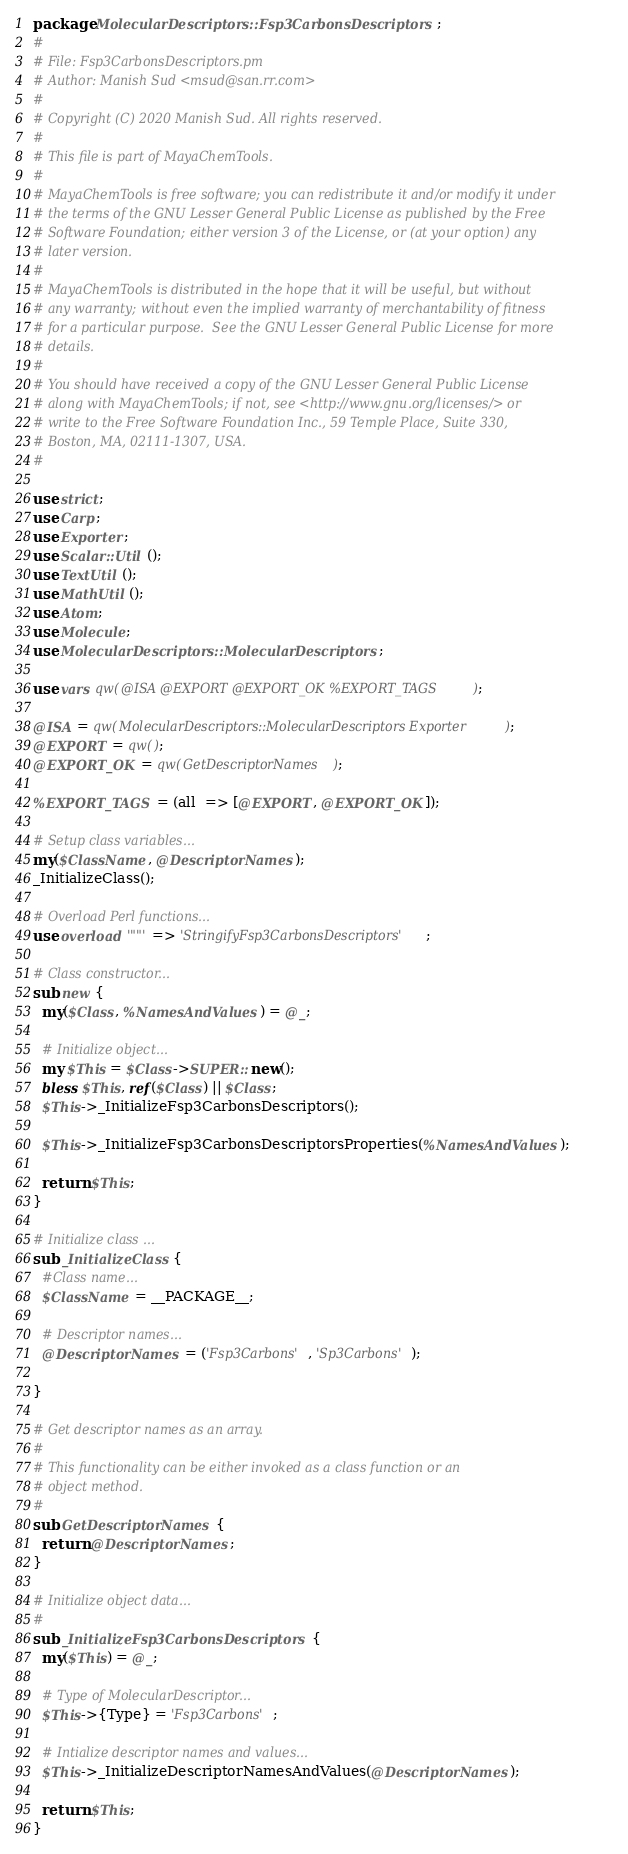Convert code to text. <code><loc_0><loc_0><loc_500><loc_500><_Perl_>package MolecularDescriptors::Fsp3CarbonsDescriptors;
#
# File: Fsp3CarbonsDescriptors.pm
# Author: Manish Sud <msud@san.rr.com>
#
# Copyright (C) 2020 Manish Sud. All rights reserved.
#
# This file is part of MayaChemTools.
#
# MayaChemTools is free software; you can redistribute it and/or modify it under
# the terms of the GNU Lesser General Public License as published by the Free
# Software Foundation; either version 3 of the License, or (at your option) any
# later version.
#
# MayaChemTools is distributed in the hope that it will be useful, but without
# any warranty; without even the implied warranty of merchantability of fitness
# for a particular purpose.  See the GNU Lesser General Public License for more
# details.
#
# You should have received a copy of the GNU Lesser General Public License
# along with MayaChemTools; if not, see <http://www.gnu.org/licenses/> or
# write to the Free Software Foundation Inc., 59 Temple Place, Suite 330,
# Boston, MA, 02111-1307, USA.
#

use strict;
use Carp;
use Exporter;
use Scalar::Util ();
use TextUtil ();
use MathUtil ();
use Atom;
use Molecule;
use MolecularDescriptors::MolecularDescriptors;

use vars qw(@ISA @EXPORT @EXPORT_OK %EXPORT_TAGS);

@ISA = qw(MolecularDescriptors::MolecularDescriptors Exporter);
@EXPORT = qw();
@EXPORT_OK = qw(GetDescriptorNames);

%EXPORT_TAGS = (all  => [@EXPORT, @EXPORT_OK]);

# Setup class variables...
my($ClassName, @DescriptorNames);
_InitializeClass();

# Overload Perl functions...
use overload '""' => 'StringifyFsp3CarbonsDescriptors';

# Class constructor...
sub new {
  my($Class, %NamesAndValues) = @_;

  # Initialize object...
  my $This = $Class->SUPER::new();
  bless $This, ref($Class) || $Class;
  $This->_InitializeFsp3CarbonsDescriptors();

  $This->_InitializeFsp3CarbonsDescriptorsProperties(%NamesAndValues);

  return $This;
}

# Initialize class ...
sub _InitializeClass {
  #Class name...
  $ClassName = __PACKAGE__;

  # Descriptor names...
  @DescriptorNames = ('Fsp3Carbons', 'Sp3Carbons');

}

# Get descriptor names as an array.
#
# This functionality can be either invoked as a class function or an
# object method.
#
sub GetDescriptorNames {
  return @DescriptorNames;
}

# Initialize object data...
#
sub _InitializeFsp3CarbonsDescriptors {
  my($This) = @_;

  # Type of MolecularDescriptor...
  $This->{Type} = 'Fsp3Carbons';

  # Intialize descriptor names and values...
  $This->_InitializeDescriptorNamesAndValues(@DescriptorNames);

  return $This;
}
</code> 